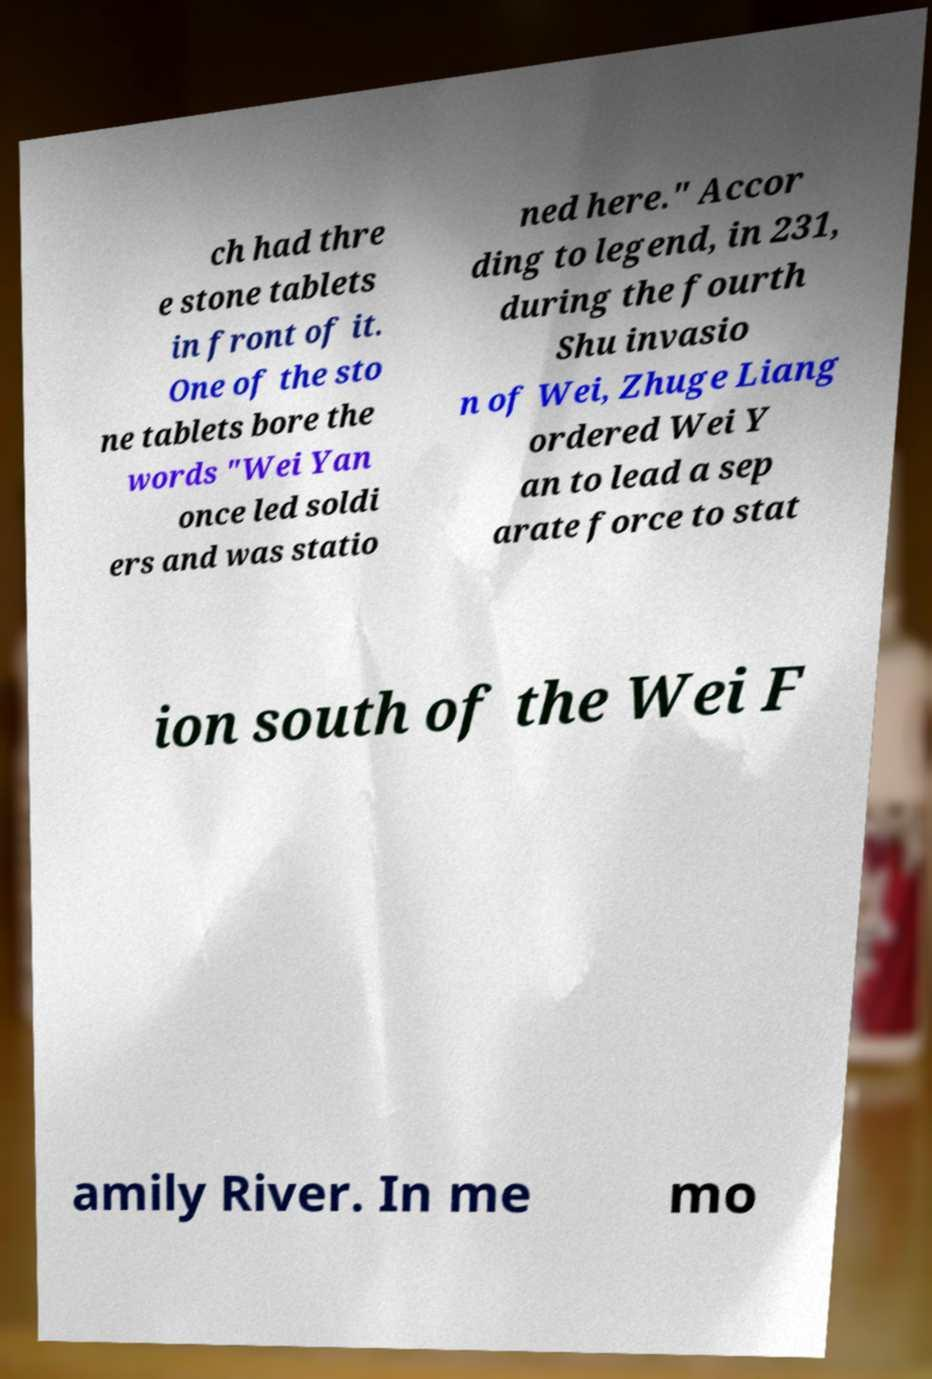I need the written content from this picture converted into text. Can you do that? ch had thre e stone tablets in front of it. One of the sto ne tablets bore the words "Wei Yan once led soldi ers and was statio ned here." Accor ding to legend, in 231, during the fourth Shu invasio n of Wei, Zhuge Liang ordered Wei Y an to lead a sep arate force to stat ion south of the Wei F amily River. In me mo 